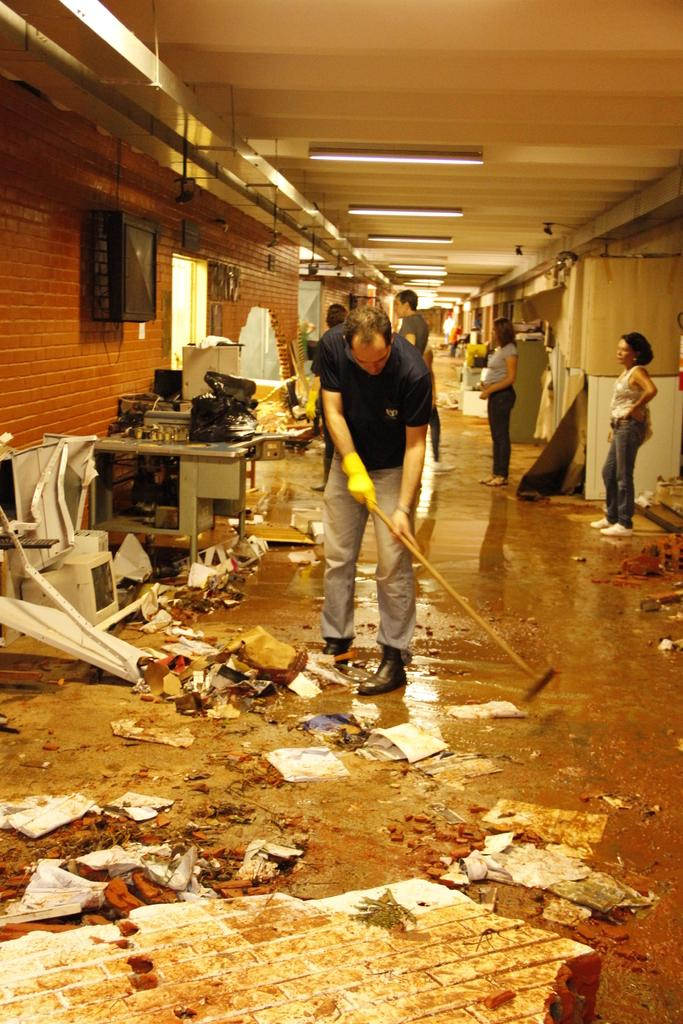What is the person in the image doing? There is a person cleaning the floor in the image. Are there any other people present in the image? Yes, there are people standing at the back side of the image. What can be seen at the top of the image? There are lights visible at the top of the image. What is located on the left side of the image? There appears to be a TV on the left side of the image. What type of government is depicted in the image? There is no depiction of a government in the image; it features a person cleaning the floor, people standing at the back, lights at the top, and a TV on the left. Can you hear the waves in the image? There are no waves present in the image, so it is not possible to hear them. 